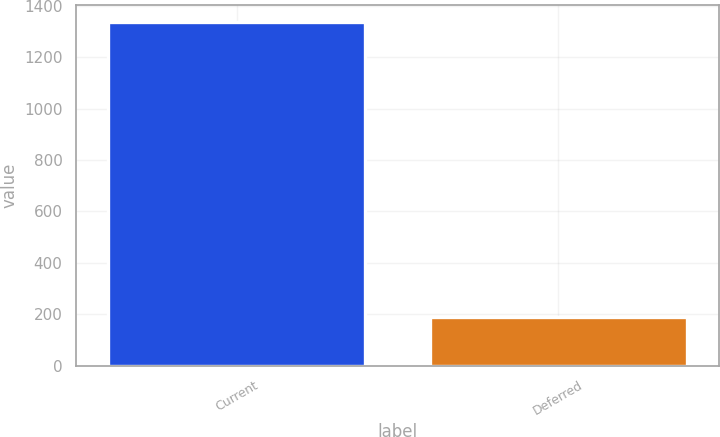Convert chart to OTSL. <chart><loc_0><loc_0><loc_500><loc_500><bar_chart><fcel>Current<fcel>Deferred<nl><fcel>1336<fcel>188<nl></chart> 